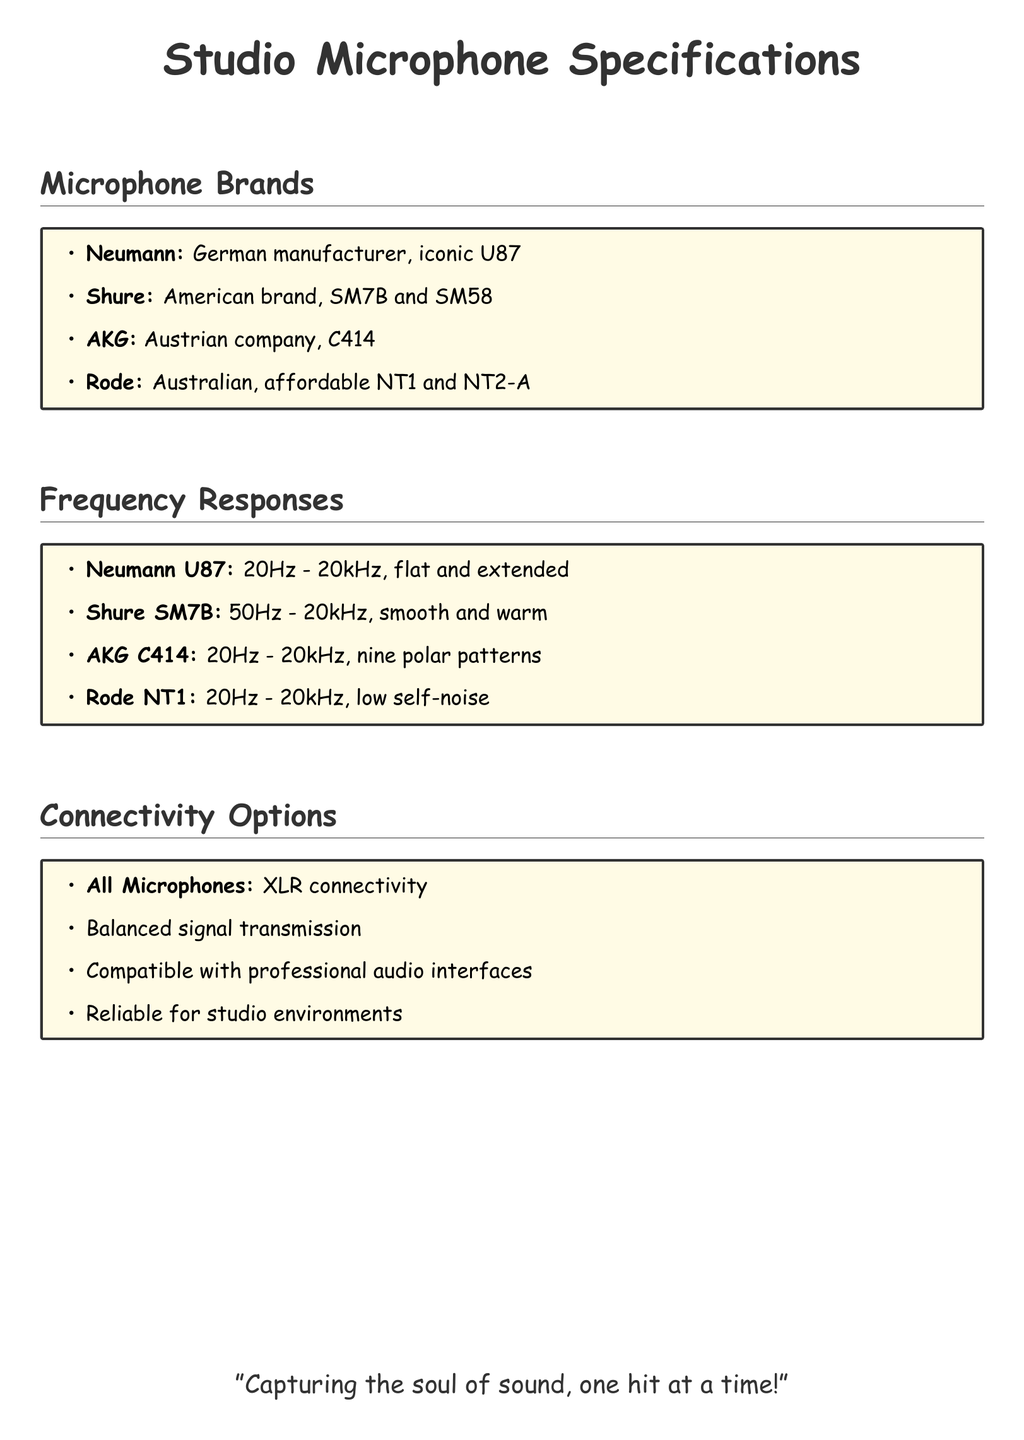What brands are mentioned? The document lists the brands of microphones as Neumann, Shure, AKG, and Rode.
Answer: Neumann, Shure, AKG, Rode What is the frequency response of Neumann U87? The Neumann U87 has a frequency response range specified in the document.
Answer: 20Hz - 20kHz Which microphone is known for a smooth and warm response? The Shure SM7B is particularly noted for having a smooth and warm frequency response.
Answer: Shure SM7B How many polar patterns does the AKG C414 have? The AKG C414 is described to have nine polar patterns in the document.
Answer: Nine What type of connectivity do all microphones use? The document states that all microphones utilize a specific type of connectivity for professional use.
Answer: XLR connectivity Which microphone has low self-noise? The Rode NT1 is mentioned as having a low self-noise feature.
Answer: Rode NT1 What is common among the mentioned microphones regarding signal transmission? The document highlights that all mentioned microphones provide a specific type of signal transmission.
Answer: Balanced signal transmission How many microphone brands are listed in total? By counting the distinct brands in the section, we can determine the total number of brands mentioned.
Answer: Four 